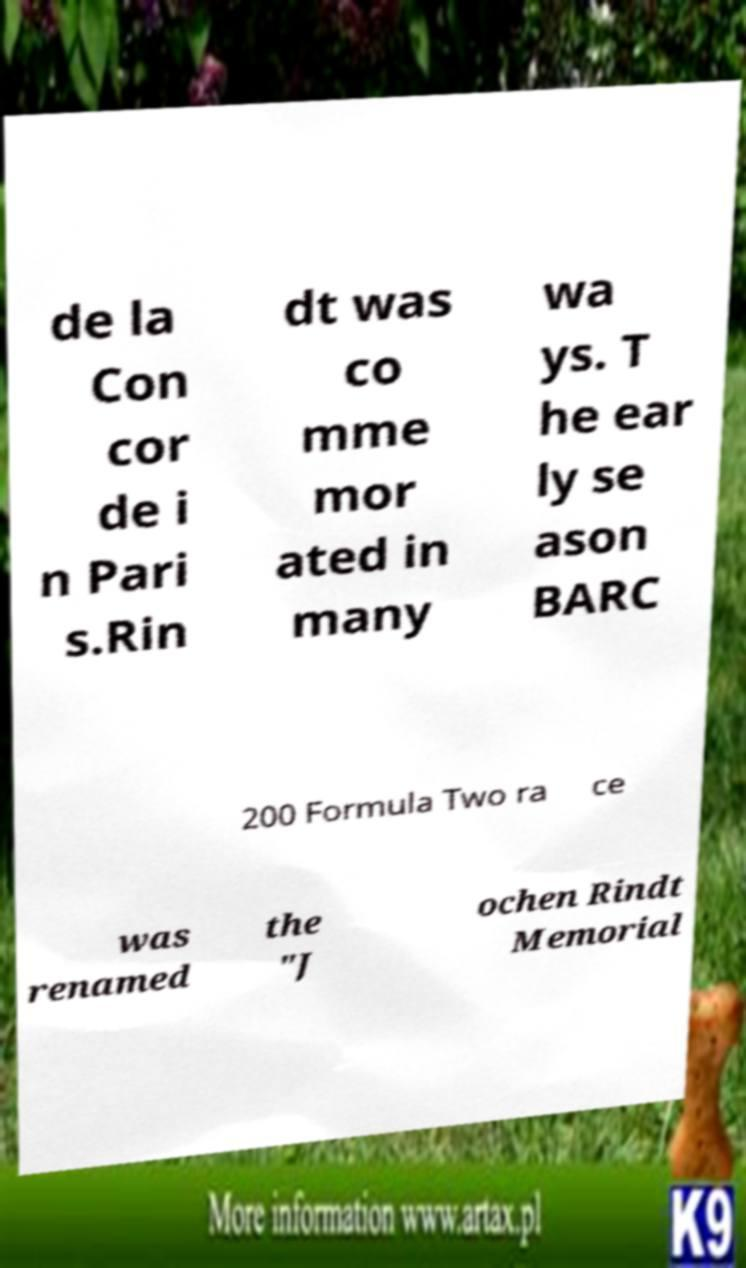I need the written content from this picture converted into text. Can you do that? de la Con cor de i n Pari s.Rin dt was co mme mor ated in many wa ys. T he ear ly se ason BARC 200 Formula Two ra ce was renamed the "J ochen Rindt Memorial 